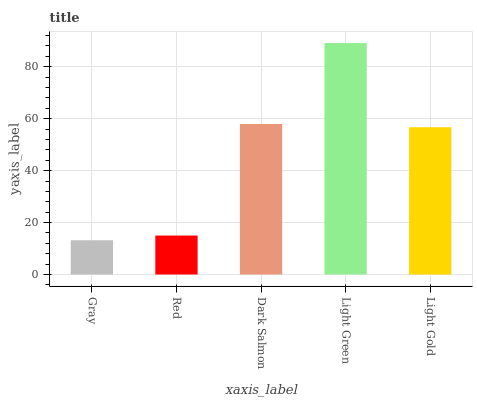Is Red the minimum?
Answer yes or no. No. Is Red the maximum?
Answer yes or no. No. Is Red greater than Gray?
Answer yes or no. Yes. Is Gray less than Red?
Answer yes or no. Yes. Is Gray greater than Red?
Answer yes or no. No. Is Red less than Gray?
Answer yes or no. No. Is Light Gold the high median?
Answer yes or no. Yes. Is Light Gold the low median?
Answer yes or no. Yes. Is Gray the high median?
Answer yes or no. No. Is Red the low median?
Answer yes or no. No. 